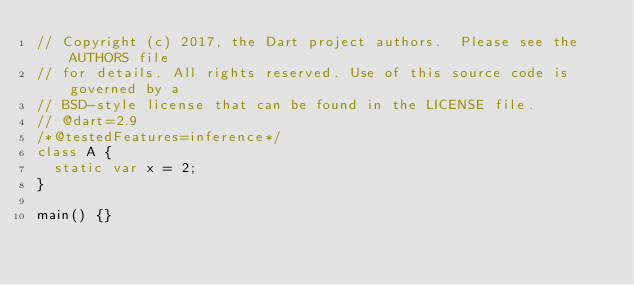<code> <loc_0><loc_0><loc_500><loc_500><_Dart_>// Copyright (c) 2017, the Dart project authors.  Please see the AUTHORS file
// for details. All rights reserved. Use of this source code is governed by a
// BSD-style license that can be found in the LICENSE file.
// @dart=2.9
/*@testedFeatures=inference*/
class A {
  static var x = 2;
}

main() {}
</code> 